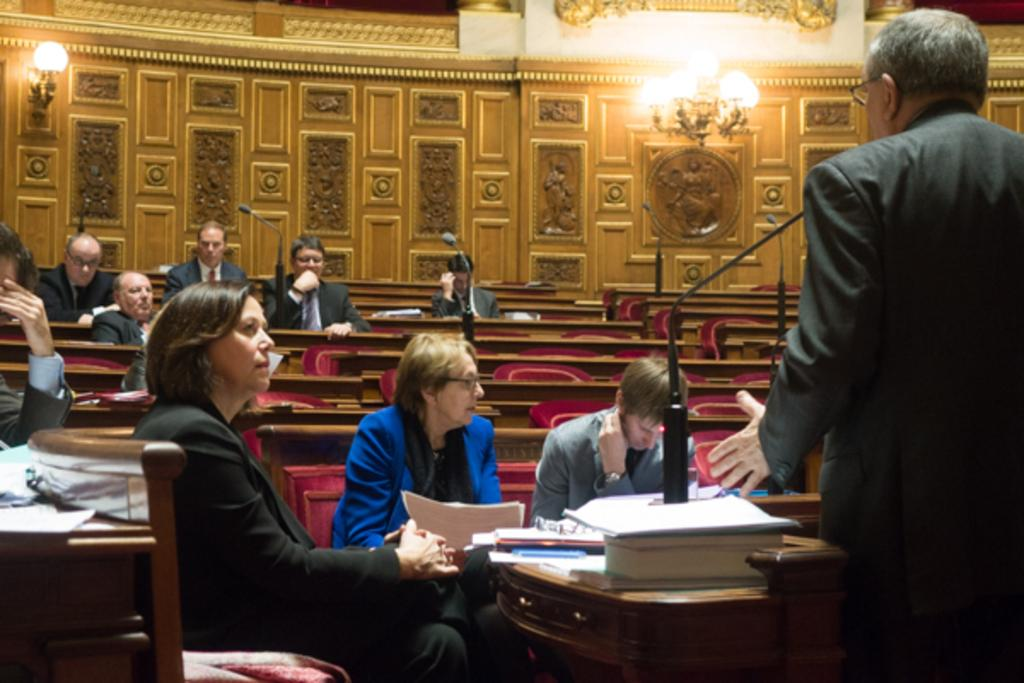What is the person in the image doing? The person is standing in the right corner of the image and speaking in front of a microphone. Who is the person speaking to in the image? The person is speaking to a group of people sitting in front of them. How far away is the ghost from the person speaking in the image? There is no ghost present in the image. 